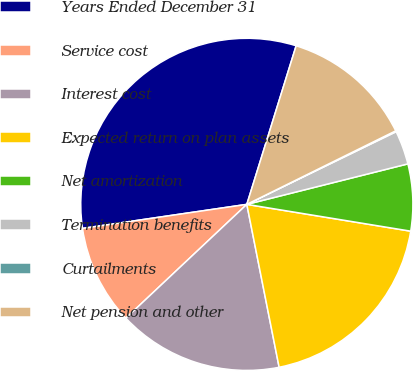<chart> <loc_0><loc_0><loc_500><loc_500><pie_chart><fcel>Years Ended December 31<fcel>Service cost<fcel>Interest cost<fcel>Expected return on plan assets<fcel>Net amortization<fcel>Termination benefits<fcel>Curtailments<fcel>Net pension and other<nl><fcel>32.11%<fcel>9.7%<fcel>16.1%<fcel>19.3%<fcel>6.5%<fcel>3.29%<fcel>0.09%<fcel>12.9%<nl></chart> 